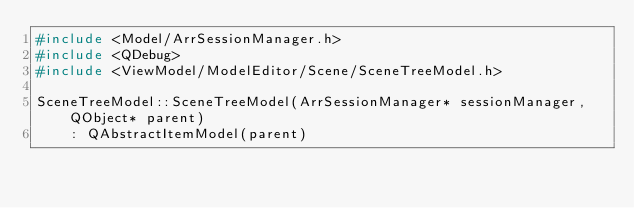<code> <loc_0><loc_0><loc_500><loc_500><_C++_>#include <Model/ArrSessionManager.h>
#include <QDebug>
#include <ViewModel/ModelEditor/Scene/SceneTreeModel.h>

SceneTreeModel::SceneTreeModel(ArrSessionManager* sessionManager, QObject* parent)
    : QAbstractItemModel(parent)</code> 